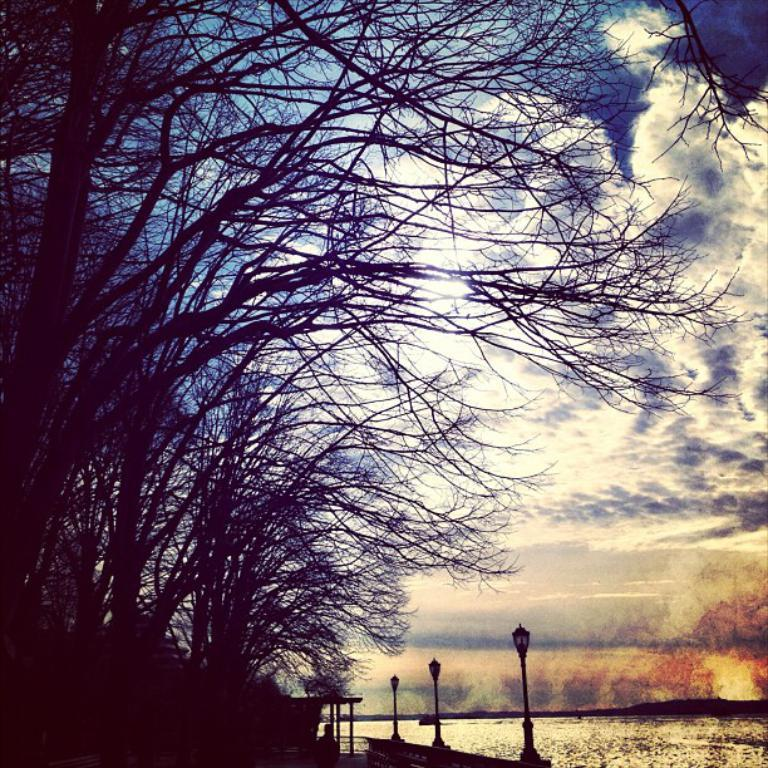What type of vegetation is present in the image? There are many trees in the image. What structures can be seen in the image besides the trees? There are street light poles in the image. How are the street light poles positioned in the image? The street light poles are standing on the ground. Where is the mailbox located in the image? There is no mailbox present in the image. Can you describe the door on the tree in the image? There is no door on any of the trees in the image. 